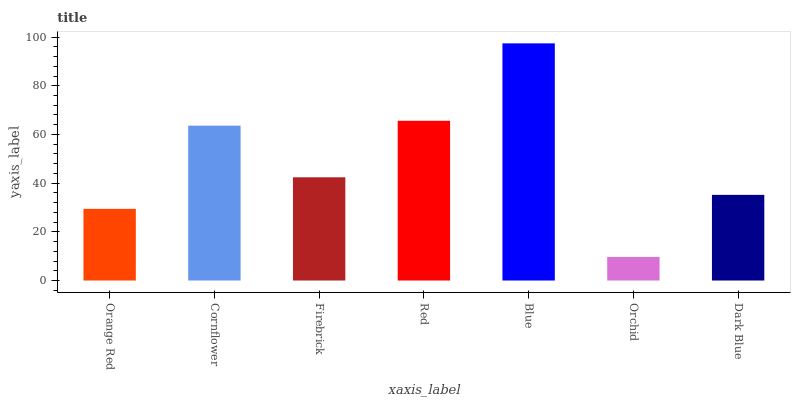Is Cornflower the minimum?
Answer yes or no. No. Is Cornflower the maximum?
Answer yes or no. No. Is Cornflower greater than Orange Red?
Answer yes or no. Yes. Is Orange Red less than Cornflower?
Answer yes or no. Yes. Is Orange Red greater than Cornflower?
Answer yes or no. No. Is Cornflower less than Orange Red?
Answer yes or no. No. Is Firebrick the high median?
Answer yes or no. Yes. Is Firebrick the low median?
Answer yes or no. Yes. Is Orchid the high median?
Answer yes or no. No. Is Orchid the low median?
Answer yes or no. No. 